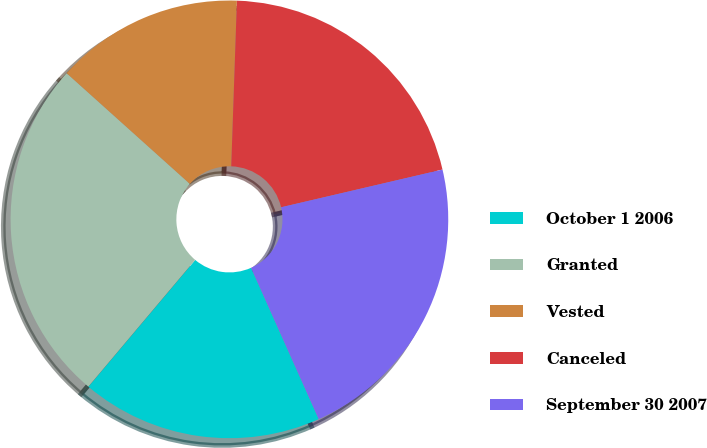Convert chart. <chart><loc_0><loc_0><loc_500><loc_500><pie_chart><fcel>October 1 2006<fcel>Granted<fcel>Vested<fcel>Canceled<fcel>September 30 2007<nl><fcel>17.84%<fcel>25.5%<fcel>13.9%<fcel>20.8%<fcel>21.96%<nl></chart> 